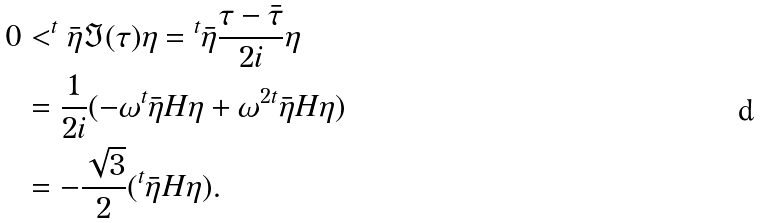Convert formula to latex. <formula><loc_0><loc_0><loc_500><loc_500>0 & < ^ { t } \bar { \eta } \Im ( \tau ) { \eta } = { ^ { t } \bar { \eta } } \frac { \tau - \bar { \tau } } { 2 i } { \eta } \\ & = \frac { 1 } { 2 i } ( - \omega { ^ { t } \bar { \eta } H } \eta + \omega ^ { 2 } { ^ { t } \bar { \eta } H } \eta ) \\ & = - \frac { \sqrt { 3 } } { 2 } ( { ^ { t } \bar { \eta } } H \eta ) .</formula> 